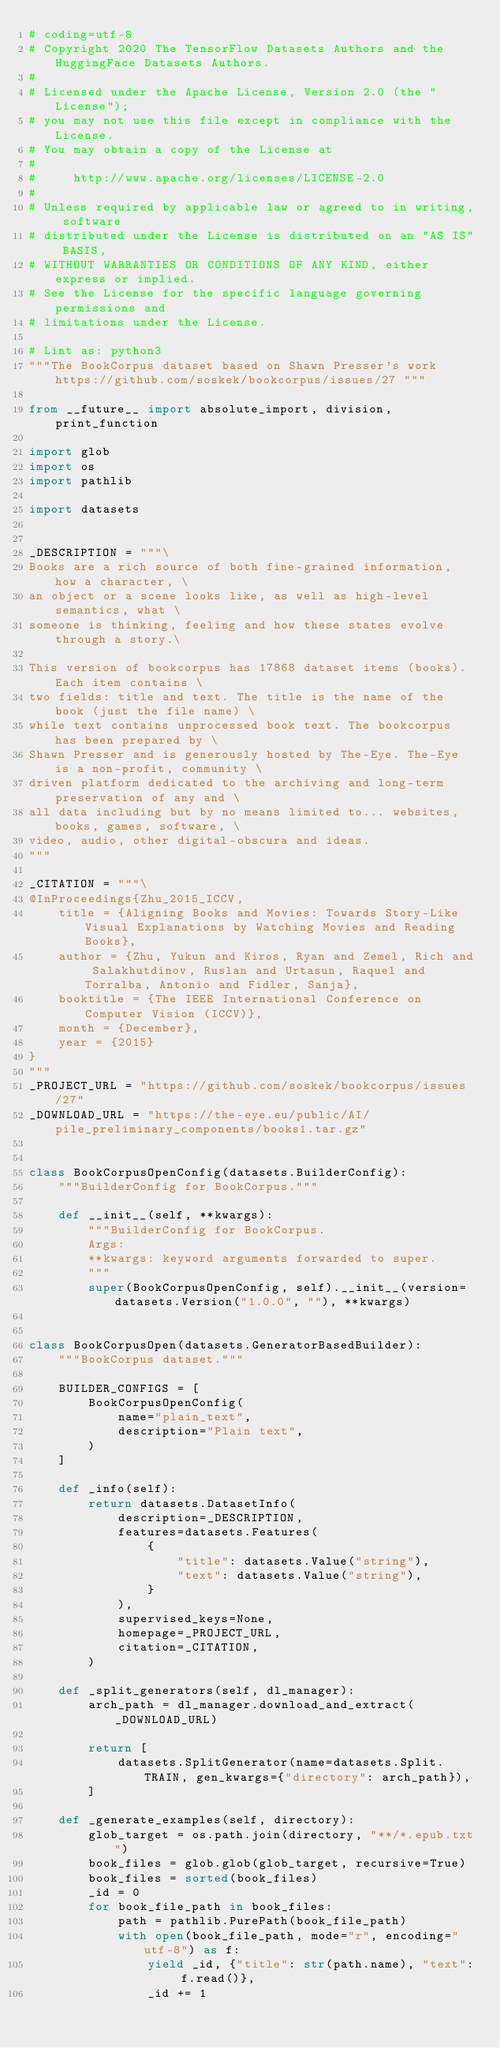Convert code to text. <code><loc_0><loc_0><loc_500><loc_500><_Python_># coding=utf-8
# Copyright 2020 The TensorFlow Datasets Authors and the HuggingFace Datasets Authors.
#
# Licensed under the Apache License, Version 2.0 (the "License");
# you may not use this file except in compliance with the License.
# You may obtain a copy of the License at
#
#     http://www.apache.org/licenses/LICENSE-2.0
#
# Unless required by applicable law or agreed to in writing, software
# distributed under the License is distributed on an "AS IS" BASIS,
# WITHOUT WARRANTIES OR CONDITIONS OF ANY KIND, either express or implied.
# See the License for the specific language governing permissions and
# limitations under the License.

# Lint as: python3
"""The BookCorpus dataset based on Shawn Presser's work https://github.com/soskek/bookcorpus/issues/27 """

from __future__ import absolute_import, division, print_function

import glob
import os
import pathlib

import datasets


_DESCRIPTION = """\
Books are a rich source of both fine-grained information, how a character, \
an object or a scene looks like, as well as high-level semantics, what \
someone is thinking, feeling and how these states evolve through a story.\

This version of bookcorpus has 17868 dataset items (books). Each item contains \
two fields: title and text. The title is the name of the book (just the file name) \
while text contains unprocessed book text. The bookcorpus has been prepared by \
Shawn Presser and is generously hosted by The-Eye. The-Eye is a non-profit, community \
driven platform dedicated to the archiving and long-term preservation of any and \
all data including but by no means limited to... websites, books, games, software, \
video, audio, other digital-obscura and ideas.
"""

_CITATION = """\
@InProceedings{Zhu_2015_ICCV,
    title = {Aligning Books and Movies: Towards Story-Like Visual Explanations by Watching Movies and Reading Books},
    author = {Zhu, Yukun and Kiros, Ryan and Zemel, Rich and Salakhutdinov, Ruslan and Urtasun, Raquel and Torralba, Antonio and Fidler, Sanja},
    booktitle = {The IEEE International Conference on Computer Vision (ICCV)},
    month = {December},
    year = {2015}
}
"""
_PROJECT_URL = "https://github.com/soskek/bookcorpus/issues/27"
_DOWNLOAD_URL = "https://the-eye.eu/public/AI/pile_preliminary_components/books1.tar.gz"


class BookCorpusOpenConfig(datasets.BuilderConfig):
    """BuilderConfig for BookCorpus."""

    def __init__(self, **kwargs):
        """BuilderConfig for BookCorpus.
        Args:
        **kwargs: keyword arguments forwarded to super.
        """
        super(BookCorpusOpenConfig, self).__init__(version=datasets.Version("1.0.0", ""), **kwargs)


class BookCorpusOpen(datasets.GeneratorBasedBuilder):
    """BookCorpus dataset."""

    BUILDER_CONFIGS = [
        BookCorpusOpenConfig(
            name="plain_text",
            description="Plain text",
        )
    ]

    def _info(self):
        return datasets.DatasetInfo(
            description=_DESCRIPTION,
            features=datasets.Features(
                {
                    "title": datasets.Value("string"),
                    "text": datasets.Value("string"),
                }
            ),
            supervised_keys=None,
            homepage=_PROJECT_URL,
            citation=_CITATION,
        )

    def _split_generators(self, dl_manager):
        arch_path = dl_manager.download_and_extract(_DOWNLOAD_URL)

        return [
            datasets.SplitGenerator(name=datasets.Split.TRAIN, gen_kwargs={"directory": arch_path}),
        ]

    def _generate_examples(self, directory):
        glob_target = os.path.join(directory, "**/*.epub.txt")
        book_files = glob.glob(glob_target, recursive=True)
        book_files = sorted(book_files)
        _id = 0
        for book_file_path in book_files:
            path = pathlib.PurePath(book_file_path)
            with open(book_file_path, mode="r", encoding="utf-8") as f:
                yield _id, {"title": str(path.name), "text": f.read()},
                _id += 1
</code> 